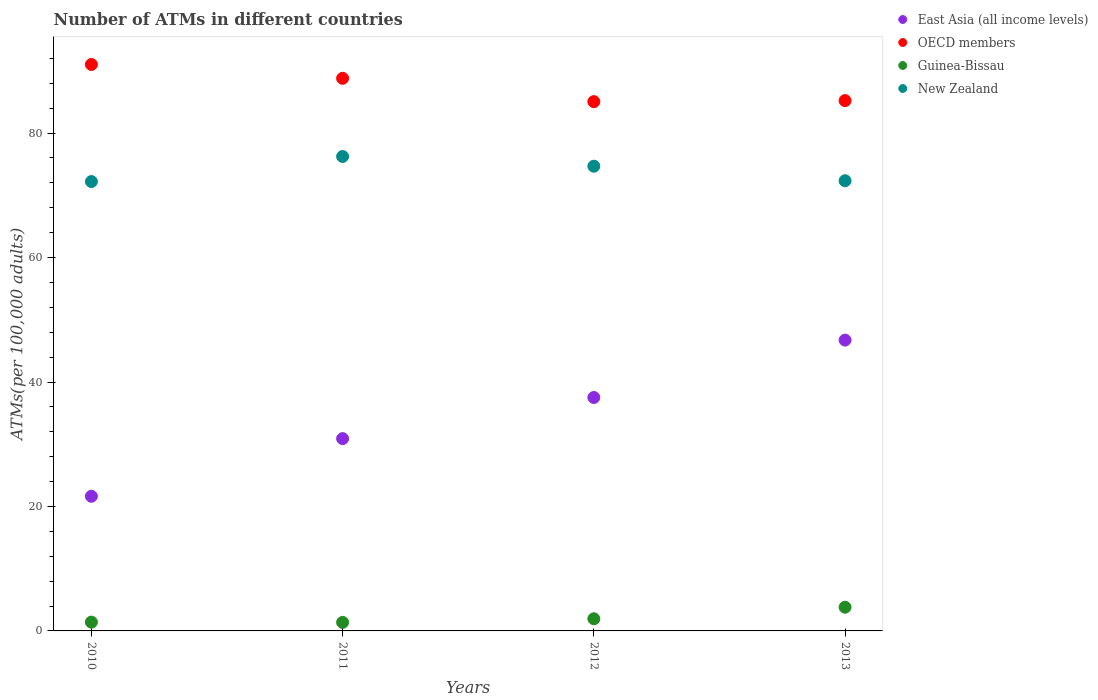What is the number of ATMs in OECD members in 2013?
Offer a very short reply. 85.23. Across all years, what is the maximum number of ATMs in East Asia (all income levels)?
Offer a very short reply. 46.74. Across all years, what is the minimum number of ATMs in New Zealand?
Offer a very short reply. 72.21. In which year was the number of ATMs in East Asia (all income levels) maximum?
Your answer should be very brief. 2013. In which year was the number of ATMs in Guinea-Bissau minimum?
Make the answer very short. 2011. What is the total number of ATMs in East Asia (all income levels) in the graph?
Provide a short and direct response. 136.79. What is the difference between the number of ATMs in New Zealand in 2010 and that in 2012?
Keep it short and to the point. -2.47. What is the difference between the number of ATMs in OECD members in 2011 and the number of ATMs in East Asia (all income levels) in 2010?
Provide a short and direct response. 67.17. What is the average number of ATMs in OECD members per year?
Provide a short and direct response. 87.53. In the year 2012, what is the difference between the number of ATMs in East Asia (all income levels) and number of ATMs in Guinea-Bissau?
Your answer should be very brief. 35.56. What is the ratio of the number of ATMs in New Zealand in 2010 to that in 2011?
Keep it short and to the point. 0.95. Is the number of ATMs in Guinea-Bissau in 2010 less than that in 2012?
Give a very brief answer. Yes. Is the difference between the number of ATMs in East Asia (all income levels) in 2011 and 2012 greater than the difference between the number of ATMs in Guinea-Bissau in 2011 and 2012?
Give a very brief answer. No. What is the difference between the highest and the second highest number of ATMs in Guinea-Bissau?
Offer a very short reply. 1.85. What is the difference between the highest and the lowest number of ATMs in OECD members?
Provide a succinct answer. 5.97. Is the sum of the number of ATMs in New Zealand in 2012 and 2013 greater than the maximum number of ATMs in OECD members across all years?
Ensure brevity in your answer.  Yes. Is it the case that in every year, the sum of the number of ATMs in OECD members and number of ATMs in New Zealand  is greater than the sum of number of ATMs in Guinea-Bissau and number of ATMs in East Asia (all income levels)?
Ensure brevity in your answer.  Yes. What is the difference between two consecutive major ticks on the Y-axis?
Your answer should be compact. 20. Does the graph contain any zero values?
Provide a succinct answer. No. Does the graph contain grids?
Give a very brief answer. No. Where does the legend appear in the graph?
Give a very brief answer. Top right. How are the legend labels stacked?
Provide a short and direct response. Vertical. What is the title of the graph?
Your response must be concise. Number of ATMs in different countries. What is the label or title of the Y-axis?
Provide a succinct answer. ATMs(per 100,0 adults). What is the ATMs(per 100,000 adults) of East Asia (all income levels) in 2010?
Ensure brevity in your answer.  21.64. What is the ATMs(per 100,000 adults) of OECD members in 2010?
Your answer should be compact. 91.03. What is the ATMs(per 100,000 adults) in Guinea-Bissau in 2010?
Your response must be concise. 1.41. What is the ATMs(per 100,000 adults) in New Zealand in 2010?
Give a very brief answer. 72.21. What is the ATMs(per 100,000 adults) in East Asia (all income levels) in 2011?
Provide a succinct answer. 30.9. What is the ATMs(per 100,000 adults) in OECD members in 2011?
Your answer should be very brief. 88.81. What is the ATMs(per 100,000 adults) of Guinea-Bissau in 2011?
Ensure brevity in your answer.  1.37. What is the ATMs(per 100,000 adults) in New Zealand in 2011?
Keep it short and to the point. 76.24. What is the ATMs(per 100,000 adults) of East Asia (all income levels) in 2012?
Make the answer very short. 37.51. What is the ATMs(per 100,000 adults) of OECD members in 2012?
Offer a terse response. 85.06. What is the ATMs(per 100,000 adults) in Guinea-Bissau in 2012?
Offer a terse response. 1.95. What is the ATMs(per 100,000 adults) in New Zealand in 2012?
Make the answer very short. 74.68. What is the ATMs(per 100,000 adults) in East Asia (all income levels) in 2013?
Offer a terse response. 46.74. What is the ATMs(per 100,000 adults) in OECD members in 2013?
Keep it short and to the point. 85.23. What is the ATMs(per 100,000 adults) in Guinea-Bissau in 2013?
Offer a very short reply. 3.81. What is the ATMs(per 100,000 adults) in New Zealand in 2013?
Ensure brevity in your answer.  72.35. Across all years, what is the maximum ATMs(per 100,000 adults) in East Asia (all income levels)?
Offer a very short reply. 46.74. Across all years, what is the maximum ATMs(per 100,000 adults) of OECD members?
Give a very brief answer. 91.03. Across all years, what is the maximum ATMs(per 100,000 adults) in Guinea-Bissau?
Your answer should be compact. 3.81. Across all years, what is the maximum ATMs(per 100,000 adults) of New Zealand?
Keep it short and to the point. 76.24. Across all years, what is the minimum ATMs(per 100,000 adults) in East Asia (all income levels)?
Offer a terse response. 21.64. Across all years, what is the minimum ATMs(per 100,000 adults) in OECD members?
Ensure brevity in your answer.  85.06. Across all years, what is the minimum ATMs(per 100,000 adults) in Guinea-Bissau?
Offer a terse response. 1.37. Across all years, what is the minimum ATMs(per 100,000 adults) of New Zealand?
Offer a very short reply. 72.21. What is the total ATMs(per 100,000 adults) of East Asia (all income levels) in the graph?
Your answer should be very brief. 136.79. What is the total ATMs(per 100,000 adults) of OECD members in the graph?
Offer a terse response. 350.12. What is the total ATMs(per 100,000 adults) of Guinea-Bissau in the graph?
Provide a short and direct response. 8.55. What is the total ATMs(per 100,000 adults) of New Zealand in the graph?
Offer a very short reply. 295.48. What is the difference between the ATMs(per 100,000 adults) of East Asia (all income levels) in 2010 and that in 2011?
Make the answer very short. -9.26. What is the difference between the ATMs(per 100,000 adults) in OECD members in 2010 and that in 2011?
Ensure brevity in your answer.  2.22. What is the difference between the ATMs(per 100,000 adults) in Guinea-Bissau in 2010 and that in 2011?
Provide a succinct answer. 0.04. What is the difference between the ATMs(per 100,000 adults) in New Zealand in 2010 and that in 2011?
Ensure brevity in your answer.  -4.03. What is the difference between the ATMs(per 100,000 adults) in East Asia (all income levels) in 2010 and that in 2012?
Your answer should be very brief. -15.87. What is the difference between the ATMs(per 100,000 adults) of OECD members in 2010 and that in 2012?
Your response must be concise. 5.97. What is the difference between the ATMs(per 100,000 adults) of Guinea-Bissau in 2010 and that in 2012?
Provide a succinct answer. -0.54. What is the difference between the ATMs(per 100,000 adults) in New Zealand in 2010 and that in 2012?
Keep it short and to the point. -2.47. What is the difference between the ATMs(per 100,000 adults) of East Asia (all income levels) in 2010 and that in 2013?
Your response must be concise. -25.1. What is the difference between the ATMs(per 100,000 adults) of OECD members in 2010 and that in 2013?
Keep it short and to the point. 5.8. What is the difference between the ATMs(per 100,000 adults) of Guinea-Bissau in 2010 and that in 2013?
Your answer should be compact. -2.4. What is the difference between the ATMs(per 100,000 adults) in New Zealand in 2010 and that in 2013?
Provide a short and direct response. -0.14. What is the difference between the ATMs(per 100,000 adults) of East Asia (all income levels) in 2011 and that in 2012?
Ensure brevity in your answer.  -6.61. What is the difference between the ATMs(per 100,000 adults) of OECD members in 2011 and that in 2012?
Provide a short and direct response. 3.75. What is the difference between the ATMs(per 100,000 adults) in Guinea-Bissau in 2011 and that in 2012?
Your answer should be compact. -0.58. What is the difference between the ATMs(per 100,000 adults) of New Zealand in 2011 and that in 2012?
Keep it short and to the point. 1.56. What is the difference between the ATMs(per 100,000 adults) of East Asia (all income levels) in 2011 and that in 2013?
Make the answer very short. -15.83. What is the difference between the ATMs(per 100,000 adults) in OECD members in 2011 and that in 2013?
Provide a succinct answer. 3.58. What is the difference between the ATMs(per 100,000 adults) in Guinea-Bissau in 2011 and that in 2013?
Provide a succinct answer. -2.44. What is the difference between the ATMs(per 100,000 adults) of New Zealand in 2011 and that in 2013?
Give a very brief answer. 3.9. What is the difference between the ATMs(per 100,000 adults) in East Asia (all income levels) in 2012 and that in 2013?
Offer a terse response. -9.22. What is the difference between the ATMs(per 100,000 adults) of OECD members in 2012 and that in 2013?
Keep it short and to the point. -0.17. What is the difference between the ATMs(per 100,000 adults) of Guinea-Bissau in 2012 and that in 2013?
Give a very brief answer. -1.85. What is the difference between the ATMs(per 100,000 adults) of New Zealand in 2012 and that in 2013?
Your answer should be compact. 2.33. What is the difference between the ATMs(per 100,000 adults) of East Asia (all income levels) in 2010 and the ATMs(per 100,000 adults) of OECD members in 2011?
Your answer should be very brief. -67.17. What is the difference between the ATMs(per 100,000 adults) of East Asia (all income levels) in 2010 and the ATMs(per 100,000 adults) of Guinea-Bissau in 2011?
Provide a succinct answer. 20.27. What is the difference between the ATMs(per 100,000 adults) in East Asia (all income levels) in 2010 and the ATMs(per 100,000 adults) in New Zealand in 2011?
Offer a very short reply. -54.6. What is the difference between the ATMs(per 100,000 adults) in OECD members in 2010 and the ATMs(per 100,000 adults) in Guinea-Bissau in 2011?
Your response must be concise. 89.66. What is the difference between the ATMs(per 100,000 adults) of OECD members in 2010 and the ATMs(per 100,000 adults) of New Zealand in 2011?
Your answer should be very brief. 14.79. What is the difference between the ATMs(per 100,000 adults) in Guinea-Bissau in 2010 and the ATMs(per 100,000 adults) in New Zealand in 2011?
Keep it short and to the point. -74.83. What is the difference between the ATMs(per 100,000 adults) in East Asia (all income levels) in 2010 and the ATMs(per 100,000 adults) in OECD members in 2012?
Make the answer very short. -63.42. What is the difference between the ATMs(per 100,000 adults) of East Asia (all income levels) in 2010 and the ATMs(per 100,000 adults) of Guinea-Bissau in 2012?
Provide a short and direct response. 19.68. What is the difference between the ATMs(per 100,000 adults) in East Asia (all income levels) in 2010 and the ATMs(per 100,000 adults) in New Zealand in 2012?
Make the answer very short. -53.04. What is the difference between the ATMs(per 100,000 adults) in OECD members in 2010 and the ATMs(per 100,000 adults) in Guinea-Bissau in 2012?
Offer a terse response. 89.08. What is the difference between the ATMs(per 100,000 adults) of OECD members in 2010 and the ATMs(per 100,000 adults) of New Zealand in 2012?
Your response must be concise. 16.35. What is the difference between the ATMs(per 100,000 adults) in Guinea-Bissau in 2010 and the ATMs(per 100,000 adults) in New Zealand in 2012?
Give a very brief answer. -73.27. What is the difference between the ATMs(per 100,000 adults) in East Asia (all income levels) in 2010 and the ATMs(per 100,000 adults) in OECD members in 2013?
Make the answer very short. -63.59. What is the difference between the ATMs(per 100,000 adults) in East Asia (all income levels) in 2010 and the ATMs(per 100,000 adults) in Guinea-Bissau in 2013?
Offer a terse response. 17.83. What is the difference between the ATMs(per 100,000 adults) of East Asia (all income levels) in 2010 and the ATMs(per 100,000 adults) of New Zealand in 2013?
Your answer should be compact. -50.71. What is the difference between the ATMs(per 100,000 adults) in OECD members in 2010 and the ATMs(per 100,000 adults) in Guinea-Bissau in 2013?
Provide a succinct answer. 87.22. What is the difference between the ATMs(per 100,000 adults) of OECD members in 2010 and the ATMs(per 100,000 adults) of New Zealand in 2013?
Offer a very short reply. 18.68. What is the difference between the ATMs(per 100,000 adults) in Guinea-Bissau in 2010 and the ATMs(per 100,000 adults) in New Zealand in 2013?
Provide a succinct answer. -70.94. What is the difference between the ATMs(per 100,000 adults) of East Asia (all income levels) in 2011 and the ATMs(per 100,000 adults) of OECD members in 2012?
Your response must be concise. -54.16. What is the difference between the ATMs(per 100,000 adults) of East Asia (all income levels) in 2011 and the ATMs(per 100,000 adults) of Guinea-Bissau in 2012?
Ensure brevity in your answer.  28.95. What is the difference between the ATMs(per 100,000 adults) of East Asia (all income levels) in 2011 and the ATMs(per 100,000 adults) of New Zealand in 2012?
Your response must be concise. -43.78. What is the difference between the ATMs(per 100,000 adults) of OECD members in 2011 and the ATMs(per 100,000 adults) of Guinea-Bissau in 2012?
Give a very brief answer. 86.85. What is the difference between the ATMs(per 100,000 adults) of OECD members in 2011 and the ATMs(per 100,000 adults) of New Zealand in 2012?
Offer a very short reply. 14.13. What is the difference between the ATMs(per 100,000 adults) in Guinea-Bissau in 2011 and the ATMs(per 100,000 adults) in New Zealand in 2012?
Provide a short and direct response. -73.31. What is the difference between the ATMs(per 100,000 adults) in East Asia (all income levels) in 2011 and the ATMs(per 100,000 adults) in OECD members in 2013?
Offer a very short reply. -54.32. What is the difference between the ATMs(per 100,000 adults) in East Asia (all income levels) in 2011 and the ATMs(per 100,000 adults) in Guinea-Bissau in 2013?
Keep it short and to the point. 27.09. What is the difference between the ATMs(per 100,000 adults) of East Asia (all income levels) in 2011 and the ATMs(per 100,000 adults) of New Zealand in 2013?
Your response must be concise. -41.45. What is the difference between the ATMs(per 100,000 adults) of OECD members in 2011 and the ATMs(per 100,000 adults) of Guinea-Bissau in 2013?
Provide a succinct answer. 85. What is the difference between the ATMs(per 100,000 adults) of OECD members in 2011 and the ATMs(per 100,000 adults) of New Zealand in 2013?
Provide a short and direct response. 16.46. What is the difference between the ATMs(per 100,000 adults) of Guinea-Bissau in 2011 and the ATMs(per 100,000 adults) of New Zealand in 2013?
Your response must be concise. -70.97. What is the difference between the ATMs(per 100,000 adults) of East Asia (all income levels) in 2012 and the ATMs(per 100,000 adults) of OECD members in 2013?
Provide a short and direct response. -47.71. What is the difference between the ATMs(per 100,000 adults) in East Asia (all income levels) in 2012 and the ATMs(per 100,000 adults) in Guinea-Bissau in 2013?
Give a very brief answer. 33.7. What is the difference between the ATMs(per 100,000 adults) of East Asia (all income levels) in 2012 and the ATMs(per 100,000 adults) of New Zealand in 2013?
Provide a succinct answer. -34.83. What is the difference between the ATMs(per 100,000 adults) of OECD members in 2012 and the ATMs(per 100,000 adults) of Guinea-Bissau in 2013?
Provide a short and direct response. 81.25. What is the difference between the ATMs(per 100,000 adults) in OECD members in 2012 and the ATMs(per 100,000 adults) in New Zealand in 2013?
Your answer should be very brief. 12.71. What is the difference between the ATMs(per 100,000 adults) in Guinea-Bissau in 2012 and the ATMs(per 100,000 adults) in New Zealand in 2013?
Make the answer very short. -70.39. What is the average ATMs(per 100,000 adults) of East Asia (all income levels) per year?
Your answer should be very brief. 34.2. What is the average ATMs(per 100,000 adults) in OECD members per year?
Offer a terse response. 87.53. What is the average ATMs(per 100,000 adults) in Guinea-Bissau per year?
Ensure brevity in your answer.  2.14. What is the average ATMs(per 100,000 adults) of New Zealand per year?
Offer a terse response. 73.87. In the year 2010, what is the difference between the ATMs(per 100,000 adults) in East Asia (all income levels) and ATMs(per 100,000 adults) in OECD members?
Give a very brief answer. -69.39. In the year 2010, what is the difference between the ATMs(per 100,000 adults) of East Asia (all income levels) and ATMs(per 100,000 adults) of Guinea-Bissau?
Keep it short and to the point. 20.23. In the year 2010, what is the difference between the ATMs(per 100,000 adults) in East Asia (all income levels) and ATMs(per 100,000 adults) in New Zealand?
Give a very brief answer. -50.57. In the year 2010, what is the difference between the ATMs(per 100,000 adults) of OECD members and ATMs(per 100,000 adults) of Guinea-Bissau?
Ensure brevity in your answer.  89.62. In the year 2010, what is the difference between the ATMs(per 100,000 adults) in OECD members and ATMs(per 100,000 adults) in New Zealand?
Ensure brevity in your answer.  18.82. In the year 2010, what is the difference between the ATMs(per 100,000 adults) of Guinea-Bissau and ATMs(per 100,000 adults) of New Zealand?
Your response must be concise. -70.8. In the year 2011, what is the difference between the ATMs(per 100,000 adults) in East Asia (all income levels) and ATMs(per 100,000 adults) in OECD members?
Your answer should be very brief. -57.9. In the year 2011, what is the difference between the ATMs(per 100,000 adults) in East Asia (all income levels) and ATMs(per 100,000 adults) in Guinea-Bissau?
Your answer should be very brief. 29.53. In the year 2011, what is the difference between the ATMs(per 100,000 adults) in East Asia (all income levels) and ATMs(per 100,000 adults) in New Zealand?
Offer a very short reply. -45.34. In the year 2011, what is the difference between the ATMs(per 100,000 adults) of OECD members and ATMs(per 100,000 adults) of Guinea-Bissau?
Provide a succinct answer. 87.43. In the year 2011, what is the difference between the ATMs(per 100,000 adults) in OECD members and ATMs(per 100,000 adults) in New Zealand?
Offer a terse response. 12.56. In the year 2011, what is the difference between the ATMs(per 100,000 adults) of Guinea-Bissau and ATMs(per 100,000 adults) of New Zealand?
Make the answer very short. -74.87. In the year 2012, what is the difference between the ATMs(per 100,000 adults) in East Asia (all income levels) and ATMs(per 100,000 adults) in OECD members?
Offer a very short reply. -47.55. In the year 2012, what is the difference between the ATMs(per 100,000 adults) of East Asia (all income levels) and ATMs(per 100,000 adults) of Guinea-Bissau?
Offer a very short reply. 35.56. In the year 2012, what is the difference between the ATMs(per 100,000 adults) of East Asia (all income levels) and ATMs(per 100,000 adults) of New Zealand?
Your answer should be very brief. -37.17. In the year 2012, what is the difference between the ATMs(per 100,000 adults) of OECD members and ATMs(per 100,000 adults) of Guinea-Bissau?
Give a very brief answer. 83.1. In the year 2012, what is the difference between the ATMs(per 100,000 adults) of OECD members and ATMs(per 100,000 adults) of New Zealand?
Offer a very short reply. 10.38. In the year 2012, what is the difference between the ATMs(per 100,000 adults) in Guinea-Bissau and ATMs(per 100,000 adults) in New Zealand?
Your answer should be compact. -72.73. In the year 2013, what is the difference between the ATMs(per 100,000 adults) of East Asia (all income levels) and ATMs(per 100,000 adults) of OECD members?
Provide a short and direct response. -38.49. In the year 2013, what is the difference between the ATMs(per 100,000 adults) in East Asia (all income levels) and ATMs(per 100,000 adults) in Guinea-Bissau?
Provide a succinct answer. 42.93. In the year 2013, what is the difference between the ATMs(per 100,000 adults) of East Asia (all income levels) and ATMs(per 100,000 adults) of New Zealand?
Your answer should be very brief. -25.61. In the year 2013, what is the difference between the ATMs(per 100,000 adults) of OECD members and ATMs(per 100,000 adults) of Guinea-Bissau?
Offer a terse response. 81.42. In the year 2013, what is the difference between the ATMs(per 100,000 adults) of OECD members and ATMs(per 100,000 adults) of New Zealand?
Your response must be concise. 12.88. In the year 2013, what is the difference between the ATMs(per 100,000 adults) of Guinea-Bissau and ATMs(per 100,000 adults) of New Zealand?
Your answer should be compact. -68.54. What is the ratio of the ATMs(per 100,000 adults) in East Asia (all income levels) in 2010 to that in 2011?
Give a very brief answer. 0.7. What is the ratio of the ATMs(per 100,000 adults) of OECD members in 2010 to that in 2011?
Provide a short and direct response. 1.02. What is the ratio of the ATMs(per 100,000 adults) in Guinea-Bissau in 2010 to that in 2011?
Offer a very short reply. 1.03. What is the ratio of the ATMs(per 100,000 adults) in New Zealand in 2010 to that in 2011?
Provide a succinct answer. 0.95. What is the ratio of the ATMs(per 100,000 adults) in East Asia (all income levels) in 2010 to that in 2012?
Your answer should be compact. 0.58. What is the ratio of the ATMs(per 100,000 adults) of OECD members in 2010 to that in 2012?
Your response must be concise. 1.07. What is the ratio of the ATMs(per 100,000 adults) of Guinea-Bissau in 2010 to that in 2012?
Offer a terse response. 0.72. What is the ratio of the ATMs(per 100,000 adults) in New Zealand in 2010 to that in 2012?
Your answer should be compact. 0.97. What is the ratio of the ATMs(per 100,000 adults) of East Asia (all income levels) in 2010 to that in 2013?
Your answer should be very brief. 0.46. What is the ratio of the ATMs(per 100,000 adults) of OECD members in 2010 to that in 2013?
Offer a very short reply. 1.07. What is the ratio of the ATMs(per 100,000 adults) of Guinea-Bissau in 2010 to that in 2013?
Offer a very short reply. 0.37. What is the ratio of the ATMs(per 100,000 adults) in East Asia (all income levels) in 2011 to that in 2012?
Provide a short and direct response. 0.82. What is the ratio of the ATMs(per 100,000 adults) of OECD members in 2011 to that in 2012?
Keep it short and to the point. 1.04. What is the ratio of the ATMs(per 100,000 adults) of Guinea-Bissau in 2011 to that in 2012?
Provide a succinct answer. 0.7. What is the ratio of the ATMs(per 100,000 adults) in New Zealand in 2011 to that in 2012?
Make the answer very short. 1.02. What is the ratio of the ATMs(per 100,000 adults) in East Asia (all income levels) in 2011 to that in 2013?
Provide a succinct answer. 0.66. What is the ratio of the ATMs(per 100,000 adults) in OECD members in 2011 to that in 2013?
Your answer should be compact. 1.04. What is the ratio of the ATMs(per 100,000 adults) in Guinea-Bissau in 2011 to that in 2013?
Keep it short and to the point. 0.36. What is the ratio of the ATMs(per 100,000 adults) in New Zealand in 2011 to that in 2013?
Provide a short and direct response. 1.05. What is the ratio of the ATMs(per 100,000 adults) of East Asia (all income levels) in 2012 to that in 2013?
Give a very brief answer. 0.8. What is the ratio of the ATMs(per 100,000 adults) in Guinea-Bissau in 2012 to that in 2013?
Ensure brevity in your answer.  0.51. What is the ratio of the ATMs(per 100,000 adults) in New Zealand in 2012 to that in 2013?
Your answer should be compact. 1.03. What is the difference between the highest and the second highest ATMs(per 100,000 adults) in East Asia (all income levels)?
Provide a short and direct response. 9.22. What is the difference between the highest and the second highest ATMs(per 100,000 adults) of OECD members?
Offer a very short reply. 2.22. What is the difference between the highest and the second highest ATMs(per 100,000 adults) of Guinea-Bissau?
Offer a terse response. 1.85. What is the difference between the highest and the second highest ATMs(per 100,000 adults) of New Zealand?
Your answer should be compact. 1.56. What is the difference between the highest and the lowest ATMs(per 100,000 adults) of East Asia (all income levels)?
Provide a succinct answer. 25.1. What is the difference between the highest and the lowest ATMs(per 100,000 adults) in OECD members?
Give a very brief answer. 5.97. What is the difference between the highest and the lowest ATMs(per 100,000 adults) of Guinea-Bissau?
Give a very brief answer. 2.44. What is the difference between the highest and the lowest ATMs(per 100,000 adults) in New Zealand?
Offer a very short reply. 4.03. 